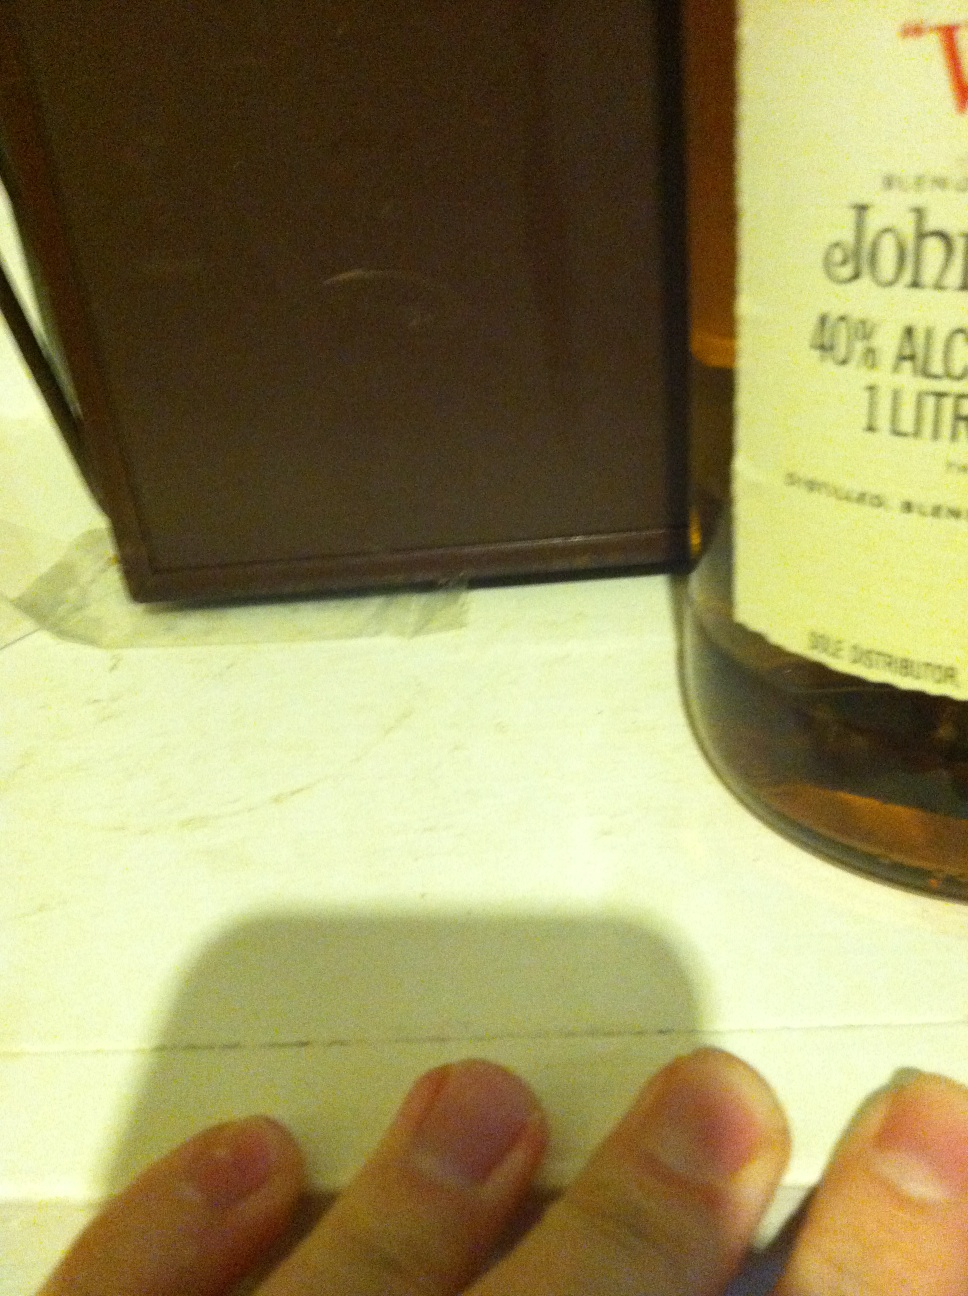Describe a realistic scenario where this whisky might be shared. A group of close friends gather for a reunion after many years apart. As they catch up on stories and reminisce about the old days, one of them brings out this bottle of whisky. They pour generous glasses, toasting to their enduring friendship and the memories they share. The whisky, with its smooth and rich flavors, enhances the warmth and camaraderie of the evening, making it a night to remember. 